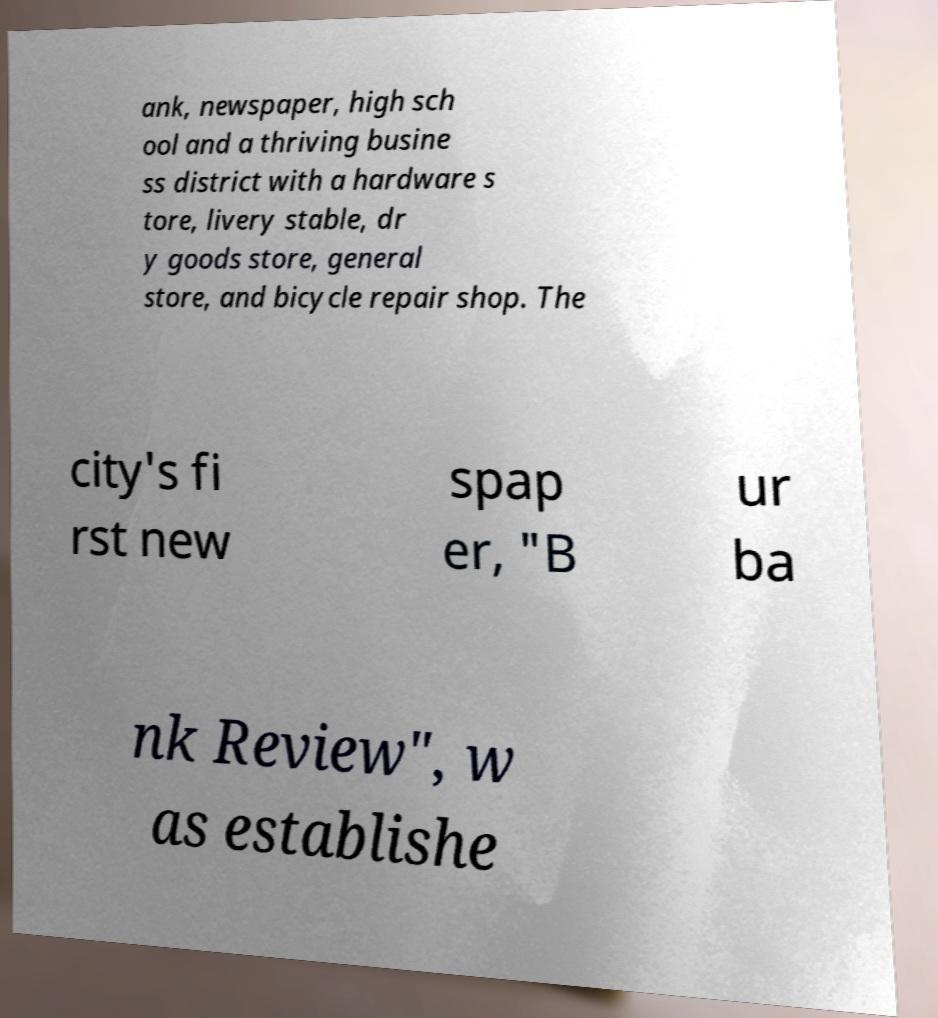Could you extract and type out the text from this image? ank, newspaper, high sch ool and a thriving busine ss district with a hardware s tore, livery stable, dr y goods store, general store, and bicycle repair shop. The city's fi rst new spap er, "B ur ba nk Review", w as establishe 